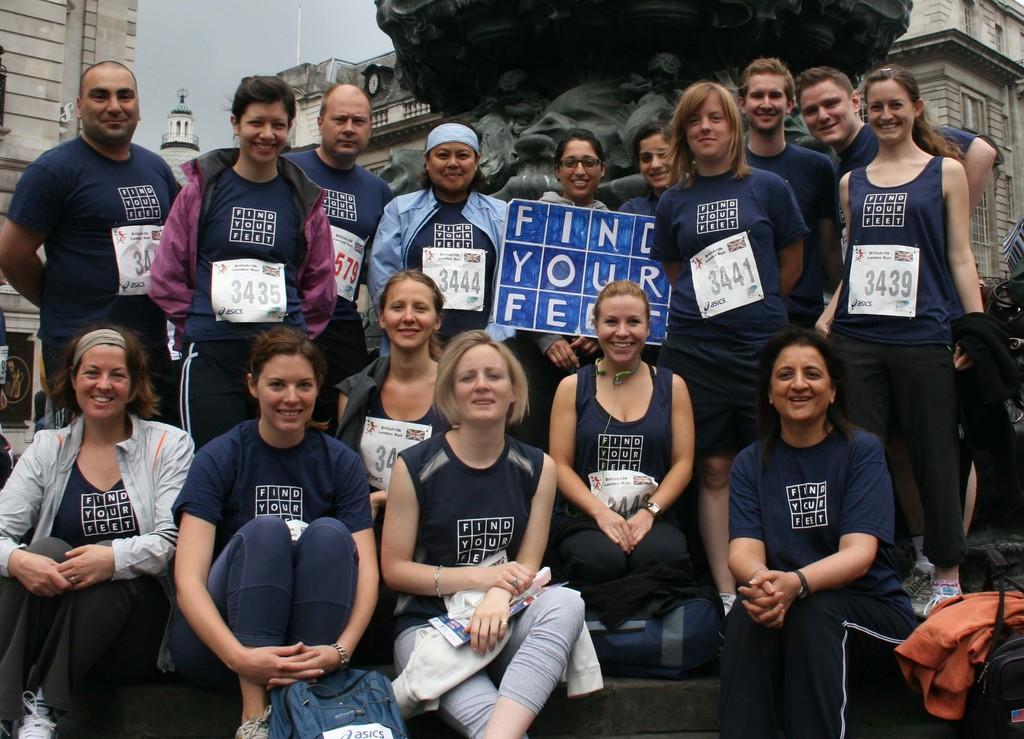Could you give a brief overview of what you see in this image? In the center of the image there are many people standing wearing blue color dress. At the bottom of the image there are girls sitting. In the background of the image there is a statue. There is a building. 